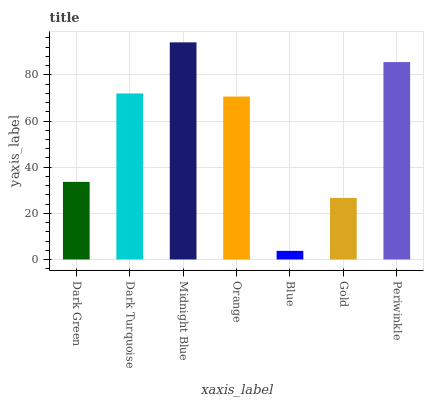Is Dark Turquoise the minimum?
Answer yes or no. No. Is Dark Turquoise the maximum?
Answer yes or no. No. Is Dark Turquoise greater than Dark Green?
Answer yes or no. Yes. Is Dark Green less than Dark Turquoise?
Answer yes or no. Yes. Is Dark Green greater than Dark Turquoise?
Answer yes or no. No. Is Dark Turquoise less than Dark Green?
Answer yes or no. No. Is Orange the high median?
Answer yes or no. Yes. Is Orange the low median?
Answer yes or no. Yes. Is Gold the high median?
Answer yes or no. No. Is Blue the low median?
Answer yes or no. No. 